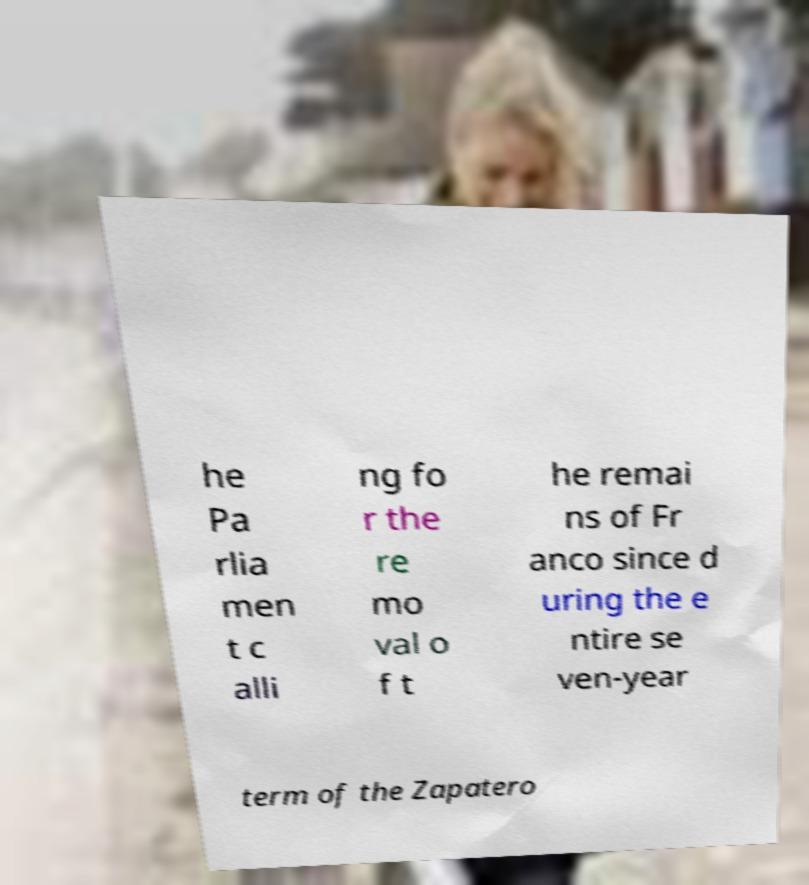There's text embedded in this image that I need extracted. Can you transcribe it verbatim? he Pa rlia men t c alli ng fo r the re mo val o f t he remai ns of Fr anco since d uring the e ntire se ven-year term of the Zapatero 